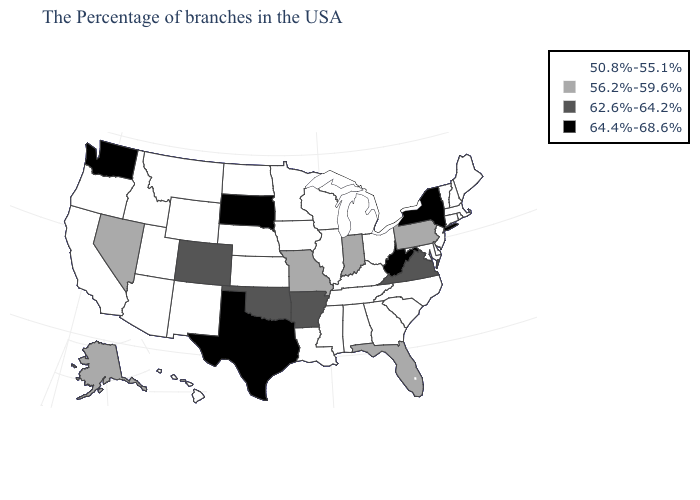Among the states that border Michigan , which have the lowest value?
Concise answer only. Ohio, Wisconsin. Does the first symbol in the legend represent the smallest category?
Concise answer only. Yes. Does Utah have the lowest value in the USA?
Concise answer only. Yes. Among the states that border Iowa , which have the highest value?
Quick response, please. South Dakota. Does Ohio have the lowest value in the USA?
Keep it brief. Yes. Does Kentucky have the highest value in the South?
Answer briefly. No. Which states have the lowest value in the USA?
Keep it brief. Maine, Massachusetts, Rhode Island, New Hampshire, Vermont, Connecticut, New Jersey, Delaware, Maryland, North Carolina, South Carolina, Ohio, Georgia, Michigan, Kentucky, Alabama, Tennessee, Wisconsin, Illinois, Mississippi, Louisiana, Minnesota, Iowa, Kansas, Nebraska, North Dakota, Wyoming, New Mexico, Utah, Montana, Arizona, Idaho, California, Oregon, Hawaii. Name the states that have a value in the range 62.6%-64.2%?
Be succinct. Virginia, Arkansas, Oklahoma, Colorado. What is the value of New Hampshire?
Answer briefly. 50.8%-55.1%. What is the lowest value in the USA?
Quick response, please. 50.8%-55.1%. Does the map have missing data?
Quick response, please. No. What is the value of West Virginia?
Short answer required. 64.4%-68.6%. Does the first symbol in the legend represent the smallest category?
Give a very brief answer. Yes. Name the states that have a value in the range 64.4%-68.6%?
Keep it brief. New York, West Virginia, Texas, South Dakota, Washington. 